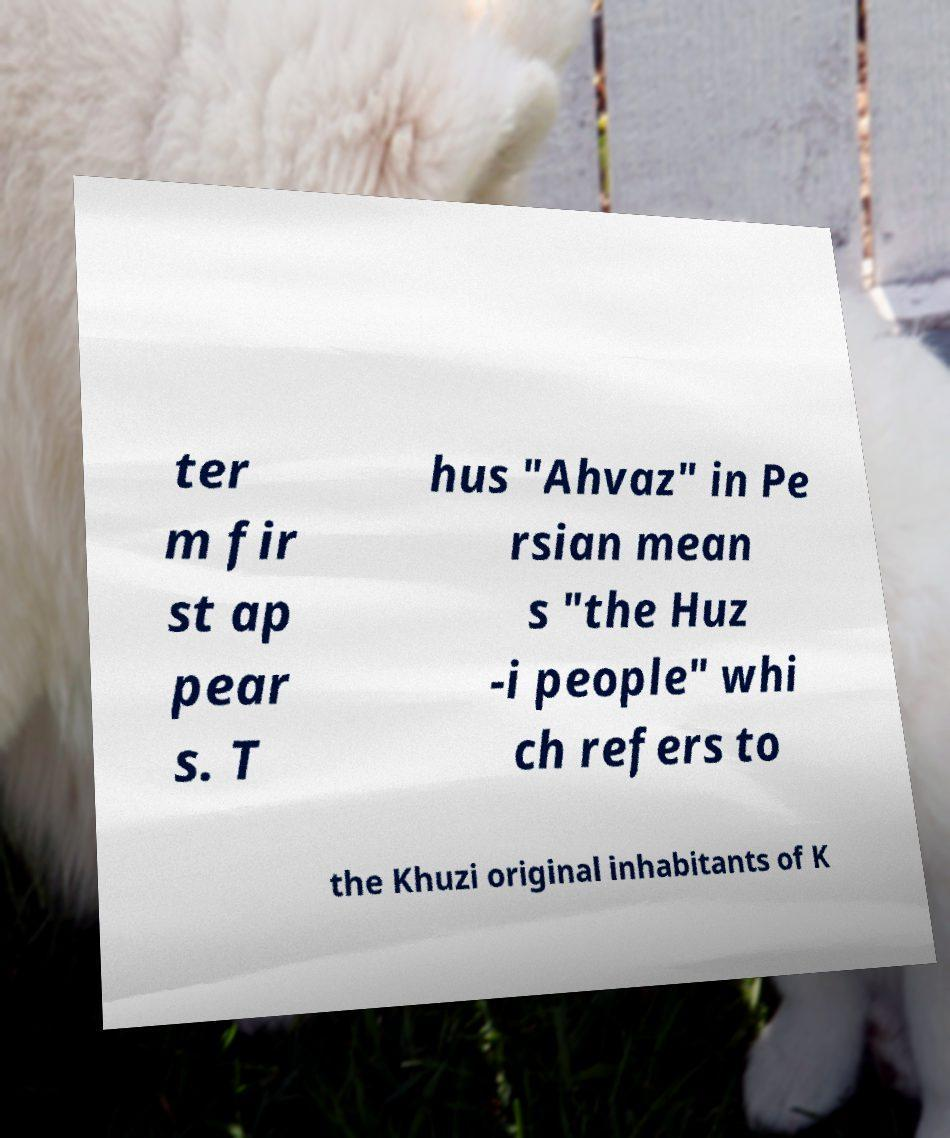Can you read and provide the text displayed in the image?This photo seems to have some interesting text. Can you extract and type it out for me? ter m fir st ap pear s. T hus "Ahvaz" in Pe rsian mean s "the Huz -i people" whi ch refers to the Khuzi original inhabitants of K 